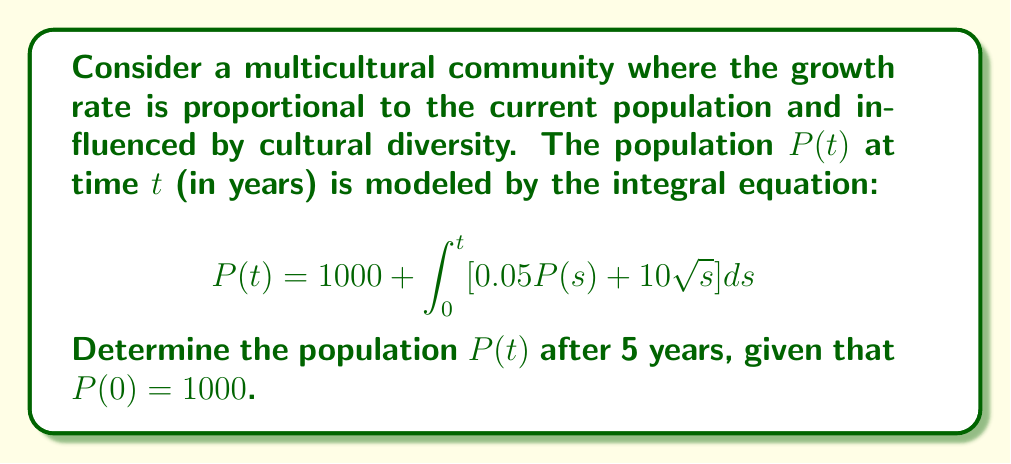Help me with this question. Let's solve this step-by-step:

1) First, we need to convert the integral equation into a differential equation. Let's differentiate both sides with respect to $t$:

   $$\frac{d}{dt}P(t) = \frac{d}{dt}\left(1000 + \int_0^t [0.05P(s) + 10\sqrt{s}] ds\right)$$

2) Using the Fundamental Theorem of Calculus, we get:

   $$\frac{dP}{dt} = 0.05P(t) + 10\sqrt{t}$$

3) This is a first-order linear differential equation. We can solve it using the integrating factor method.

4) The integrating factor is $e^{-\int 0.05 dt} = e^{-0.05t}$

5) Multiplying both sides by the integrating factor:

   $$e^{-0.05t}\frac{dP}{dt} - 0.05e^{-0.05t}P = 10e^{-0.05t}\sqrt{t}$$

6) The left side is now the derivative of $e^{-0.05t}P$. So we can write:

   $$\frac{d}{dt}(e^{-0.05t}P) = 10e^{-0.05t}\sqrt{t}$$

7) Integrating both sides:

   $$e^{-0.05t}P = \int 10e^{-0.05t}\sqrt{t} dt + C$$

8) The integral on the right side doesn't have an elementary antiderivative. We can use the substitution $u = \sqrt{t}$ to simplify it:

   $$e^{-0.05t}P = 20\int u^2e^{-0.05u^2} du + C$$

9) This integral can be evaluated using integration by parts twice, resulting in:

   $$e^{-0.05t}P = -400u^2e^{-0.05u^2} - 4000ue^{-0.05u^2} - 40000\sqrt{\pi}\text{erf}(u\sqrt{0.05}) + C$$

10) Substituting back $u = \sqrt{t}$ and solving for $P$:

    $$P = -400te^{0.05t} - 4000\sqrt{t}e^{0.05t} - 40000\sqrt{\pi}e^{0.05t}\text{erf}(\sqrt{0.05t}) + Ce^{0.05t}$$

11) Using the initial condition $P(0) = 1000$, we can find $C = 1000$

12) Therefore, the general solution is:

    $$P(t) = 1000e^{0.05t} - 400te^{0.05t} - 4000\sqrt{t}e^{0.05t} - 40000\sqrt{\pi}e^{0.05t}\text{erf}(\sqrt{0.05t})$$

13) To find $P(5)$, we substitute $t = 5$ into this equation.
Answer: $P(5) \approx 1284$ people 